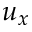Convert formula to latex. <formula><loc_0><loc_0><loc_500><loc_500>u _ { x }</formula> 